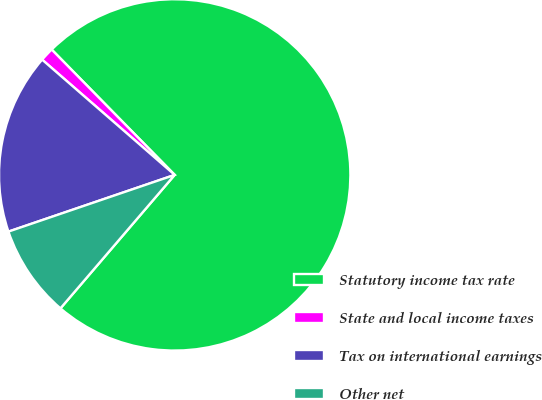<chart> <loc_0><loc_0><loc_500><loc_500><pie_chart><fcel>Statutory income tax rate<fcel>State and local income taxes<fcel>Tax on international earnings<fcel>Other net<nl><fcel>73.62%<fcel>1.26%<fcel>16.62%<fcel>8.5%<nl></chart> 